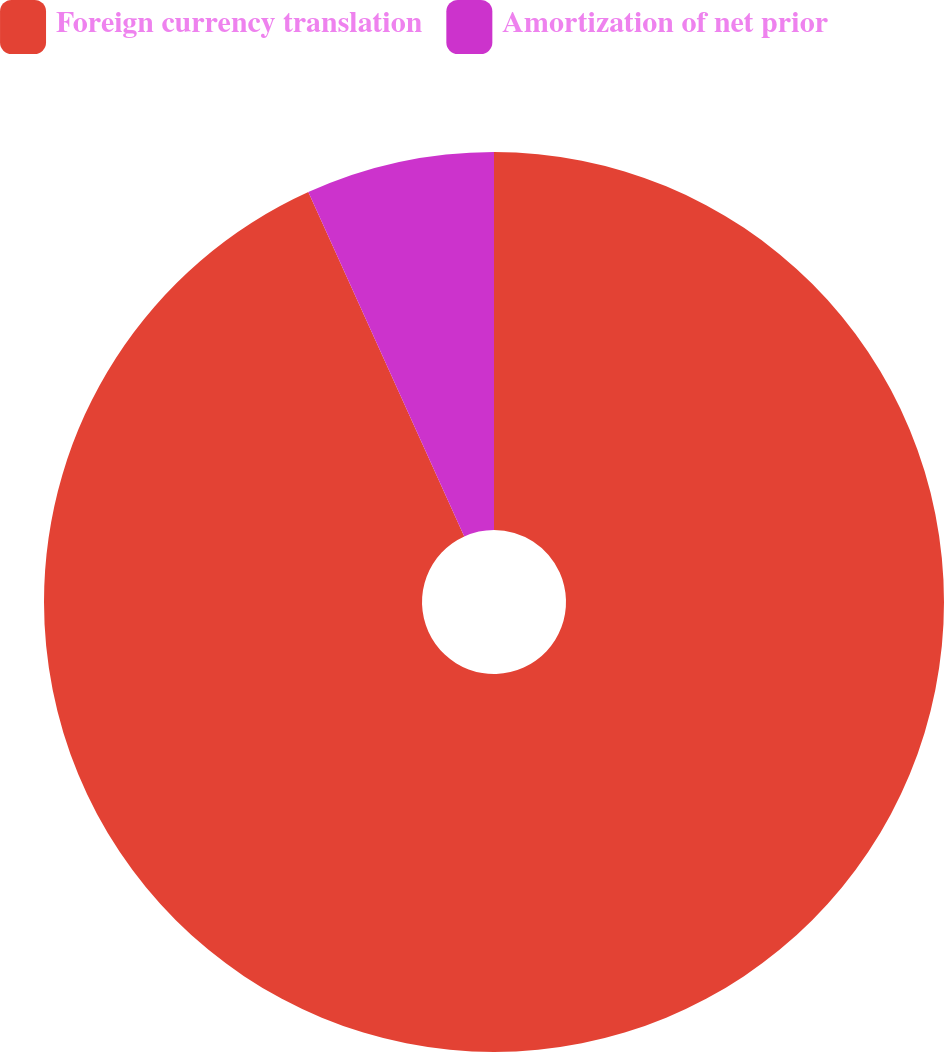Convert chart to OTSL. <chart><loc_0><loc_0><loc_500><loc_500><pie_chart><fcel>Foreign currency translation<fcel>Amortization of net prior<nl><fcel>93.23%<fcel>6.77%<nl></chart> 